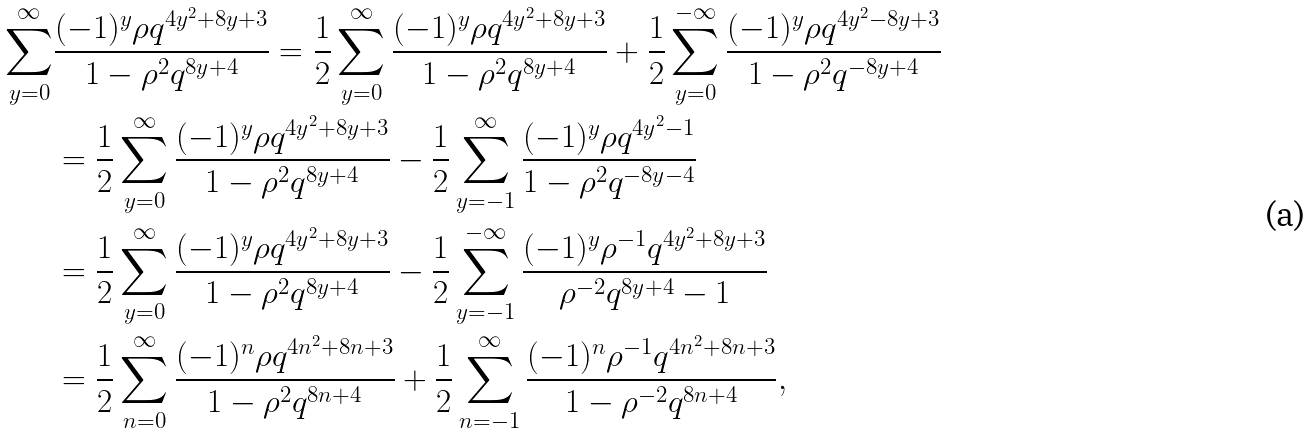<formula> <loc_0><loc_0><loc_500><loc_500>\sum _ { y = 0 } ^ { \infty } & \frac { ( - 1 ) ^ { y } \rho q ^ { 4 y ^ { 2 } + 8 y + 3 } } { 1 - \rho ^ { 2 } q ^ { 8 y + 4 } } = \frac { 1 } { 2 } \sum _ { y = 0 } ^ { \infty } \frac { ( - 1 ) ^ { y } \rho q ^ { 4 y ^ { 2 } + 8 y + 3 } } { 1 - \rho ^ { 2 } q ^ { 8 y + 4 } } + \frac { 1 } { 2 } \sum _ { y = 0 } ^ { - \infty } \frac { ( - 1 ) ^ { y } \rho q ^ { 4 y ^ { 2 } - 8 y + 3 } } { 1 - \rho ^ { 2 } q ^ { - 8 y + 4 } } \\ & = \frac { 1 } { 2 } \sum _ { y = 0 } ^ { \infty } \frac { ( - 1 ) ^ { y } \rho q ^ { 4 y ^ { 2 } + 8 y + 3 } } { 1 - \rho ^ { 2 } q ^ { 8 y + 4 } } - \frac { 1 } { 2 } \sum _ { y = - 1 } ^ { \infty } \frac { ( - 1 ) ^ { y } \rho q ^ { 4 y ^ { 2 } - 1 } } { 1 - \rho ^ { 2 } q ^ { - 8 y - 4 } } \\ & = \frac { 1 } { 2 } \sum _ { y = 0 } ^ { \infty } \frac { ( - 1 ) ^ { y } \rho q ^ { 4 y ^ { 2 } + 8 y + 3 } } { 1 - \rho ^ { 2 } q ^ { 8 y + 4 } } - \frac { 1 } { 2 } \sum _ { y = - 1 } ^ { - \infty } \frac { ( - 1 ) ^ { y } \rho ^ { - 1 } q ^ { 4 y ^ { 2 } + 8 y + 3 } } { \rho ^ { - 2 } q ^ { 8 y + 4 } - 1 } \\ & = \frac { 1 } { 2 } \sum _ { n = 0 } ^ { \infty } \frac { ( - 1 ) ^ { n } \rho q ^ { 4 n ^ { 2 } + 8 n + 3 } } { 1 - \rho ^ { 2 } q ^ { 8 n + 4 } } + \frac { 1 } { 2 } \sum _ { n = - 1 } ^ { \infty } \frac { ( - 1 ) ^ { n } \rho ^ { - 1 } q ^ { 4 n ^ { 2 } + 8 n + 3 } } { 1 - \rho ^ { - 2 } q ^ { 8 n + 4 } } ,</formula> 